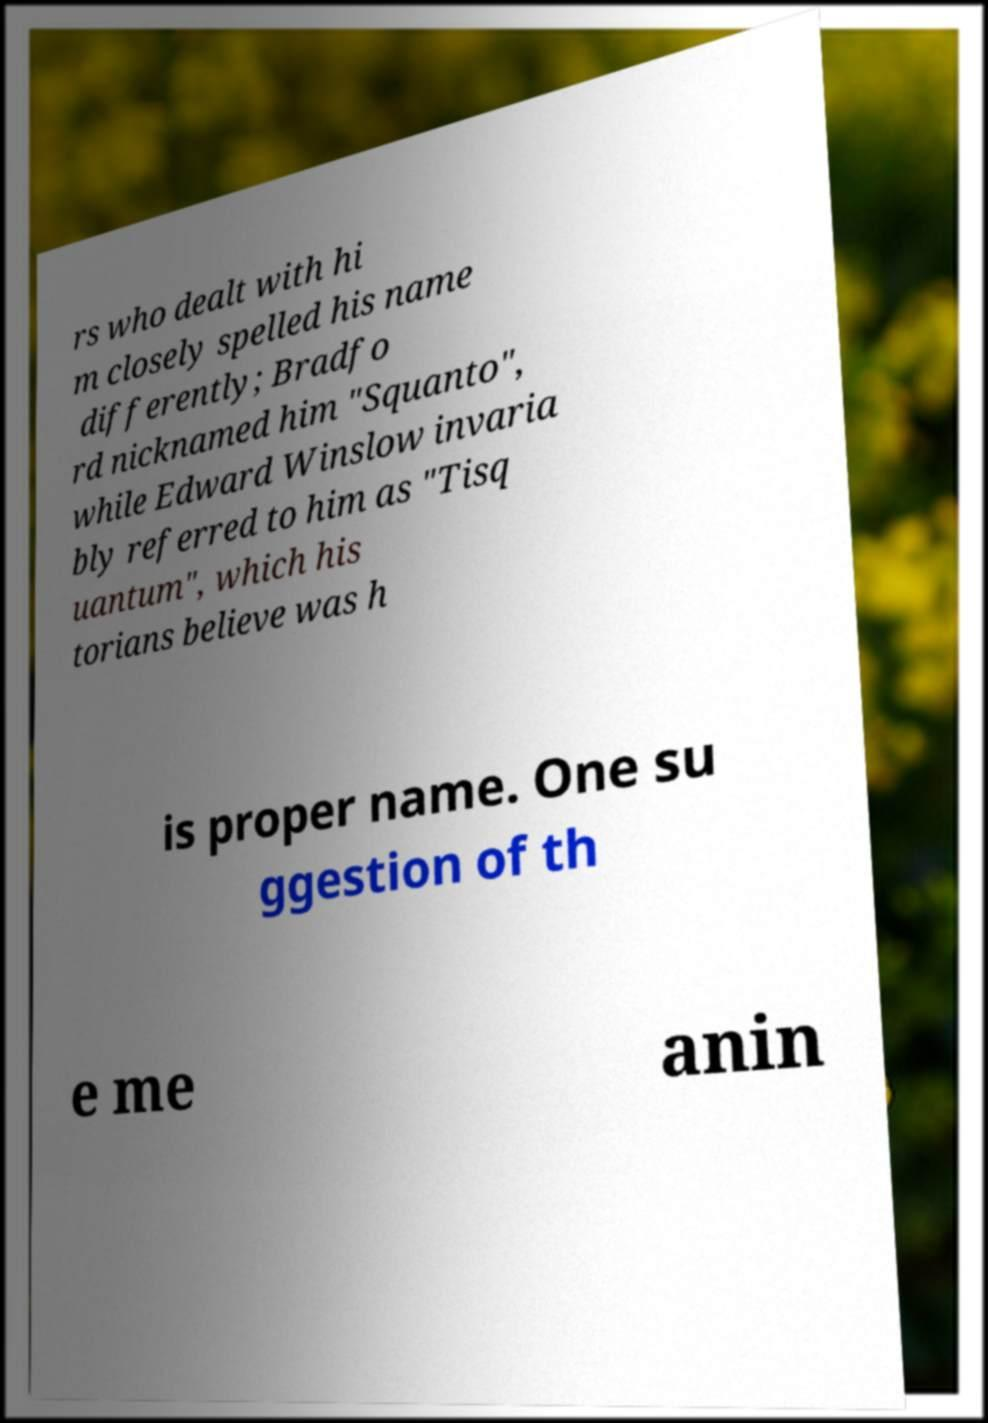What messages or text are displayed in this image? I need them in a readable, typed format. rs who dealt with hi m closely spelled his name differently; Bradfo rd nicknamed him "Squanto", while Edward Winslow invaria bly referred to him as "Tisq uantum", which his torians believe was h is proper name. One su ggestion of th e me anin 